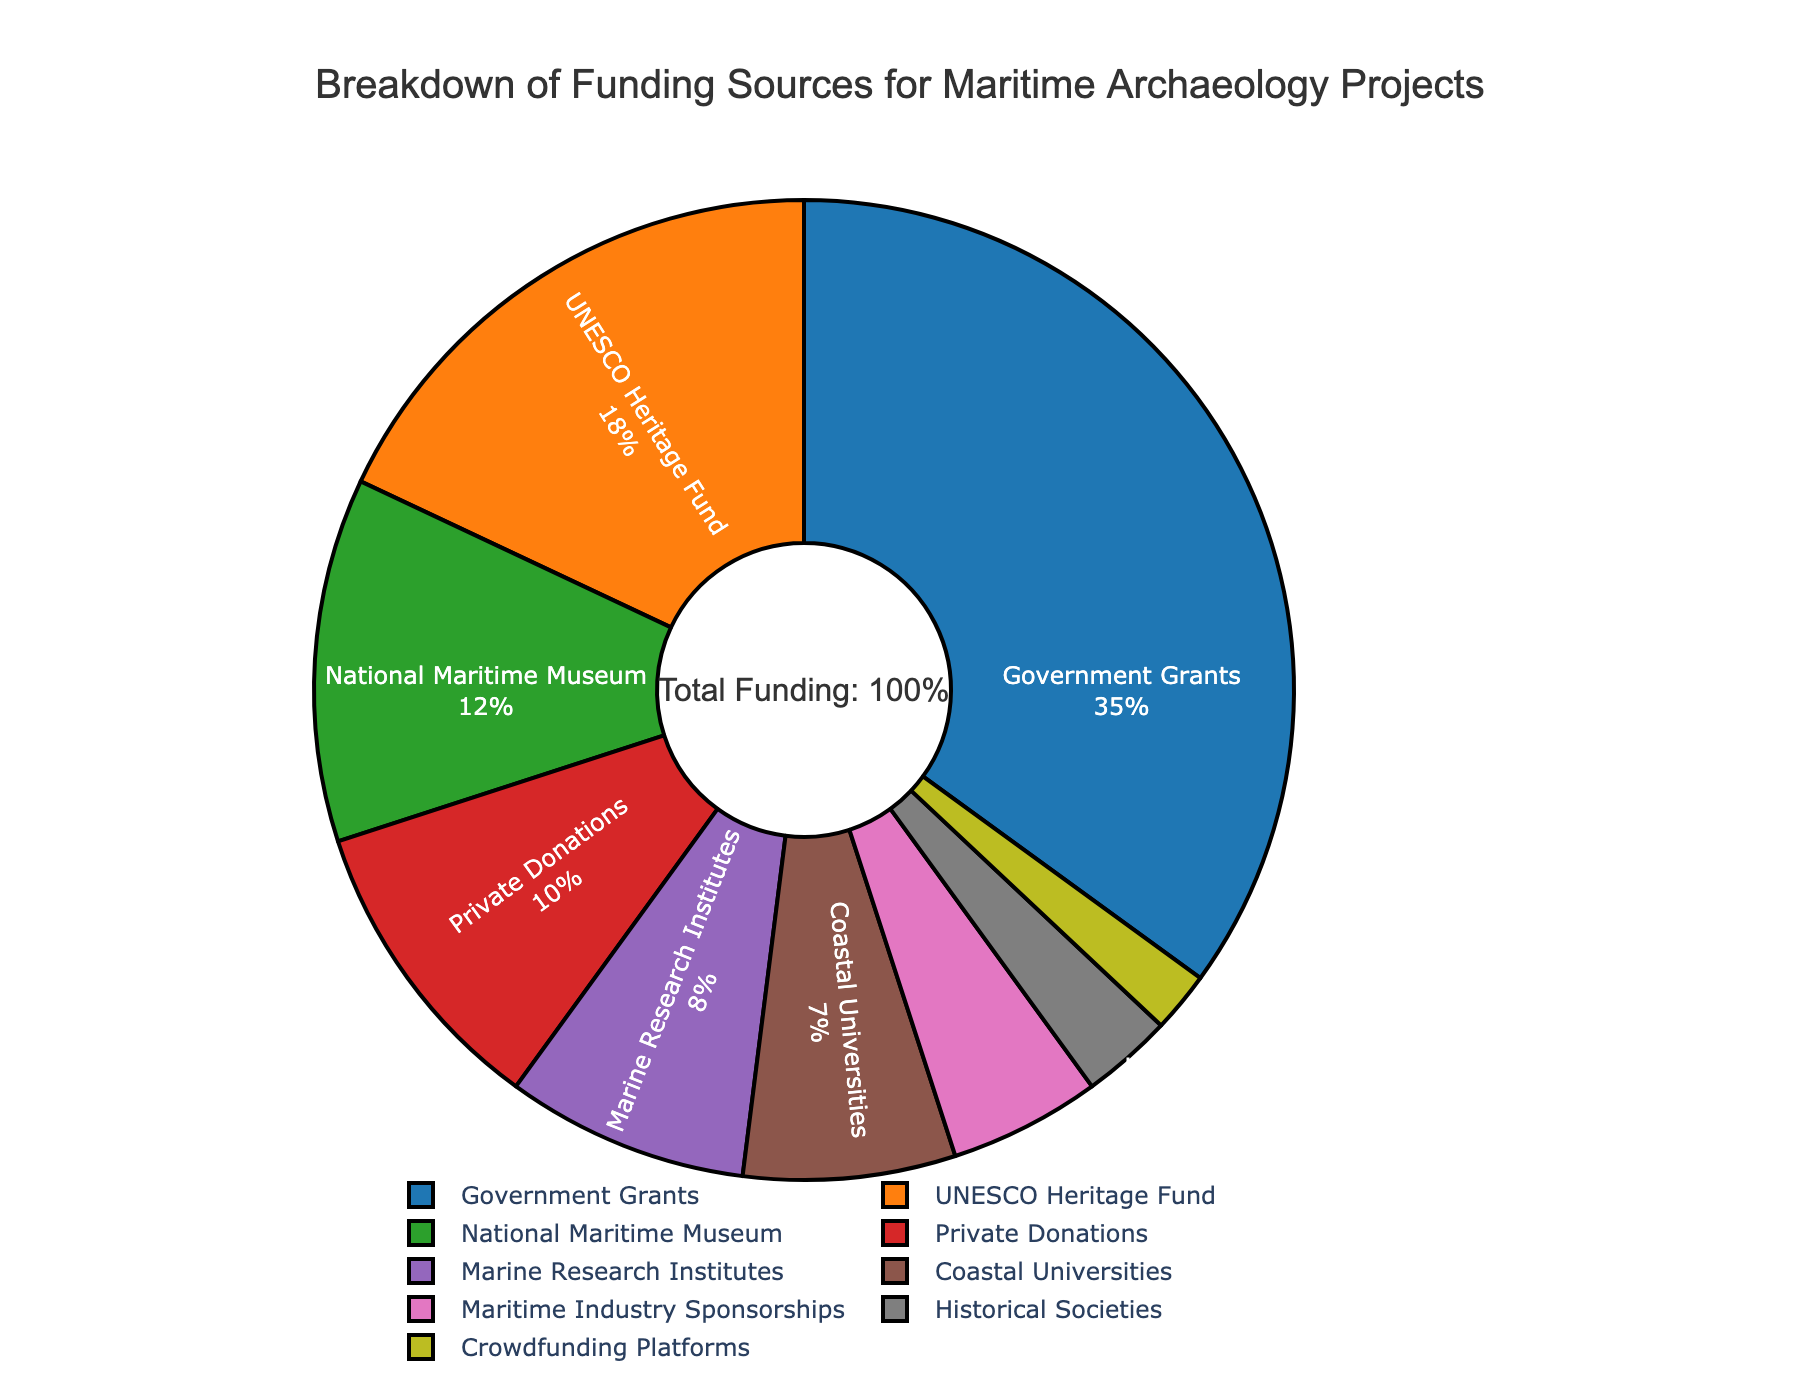Which funding source contributes the most to maritime archaeology projects? The largest section of the pie chart represents this source. By examining its label, we can identify that Government Grants contribute the most.
Answer: Government Grants What is the combined percentage of funding from the National Maritime Museum and Coastal Universities? Find the slices labeled National Maritime Museum and Coastal Universities and sum their percentages: 12% (National Maritime Museum) + 7% (Coastal Universities).
Answer: 19% How much more funding does the UNESCO Heritage Fund provide compared to Private Donations? Identify the percentages for UNESCO Heritage Fund (18%) and Private Donations (10%), then subtract the latter from the former: 18% - 10%.
Answer: 8% Which funding sources contribute least to maritime archaeology projects, and what is their combined percentage? Look at the smallest slices of the pie chart: Crowdfunding Platforms (2%) and Historical Societies (3%). Sum these percentages: 2% + 3%.
Answer: Historical Societies and Crowdfunding Platforms, 5% What is the percentage difference between Government Grants and Maritime Industry Sponsorships? Identify the percentages for Government Grants (35%) and Maritime Industry Sponsorships (5%), then subtract the latter from the former: 35% - 5%.
Answer: 30% What is the total percentage of funding contributions from private entities (Private Donations and Crowdfunding Platforms)? Add the percentages from Private Donations (10%) and Crowdfunding Platforms (2%): 10% + 2%.
Answer: 12% Which funding source associated with academia contributes more, Coastal Universities or Marine Research Institutes, and by how much? Identify the percentages for Coastal Universities (7%) and Marine Research Institutes (8%), then find the difference: 8% - 7%.
Answer: Marine Research Institutes, 1% What proportion of the total funding is provided by the top three sources combined? Identify the top three sources: Government Grants (35%), UNESCO Heritage Fund (18%), and National Maritime Museum (12%), then sum their percentages: 35% + 18% + 12%.
Answer: 65% Which funding sources are equally contributing at least 10% each? Identify the slices that show at least 10% contribution each: Government Grants (35%), UNESCO Heritage Fund (18%), National Maritime Museum (12%), and Private Donations (10%). Each of these percentages is clearly visible on their respective slices.
Answer: Government Grants, UNESCO Heritage Fund, National Maritime Museum, Private Donations How does the contribution from the National Maritime Museum compare to the combined contributions from Historical Societies and Crowdfunding Platforms, and which is larger? Identify the percentages for National Maritime Museum (12%), Historical Societies (3%), and Crowdfunding Platforms (2%). Sum Historical Societies and Crowdfunding Platforms: 3% + 2% = 5%. Compare 12% to 5%; the National Maritime Museum's contribution is larger.
Answer: National Maritime Museum, 12% 